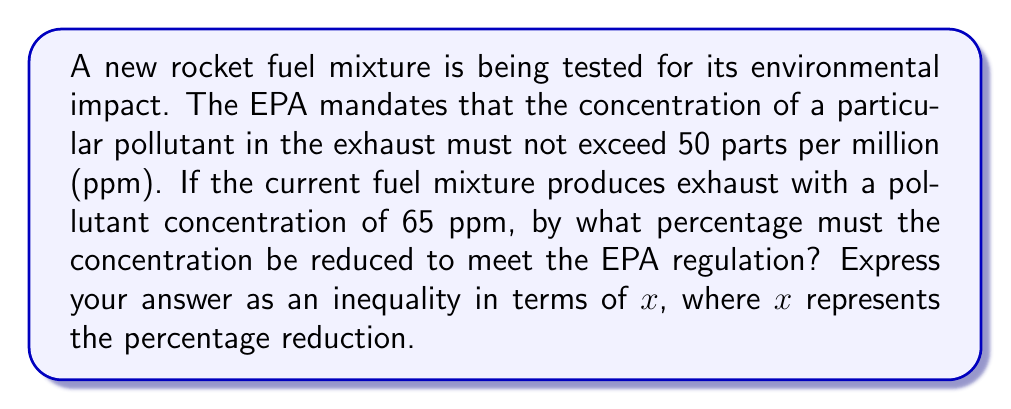Can you solve this math problem? Let's approach this step-by-step:

1) The current concentration is 65 ppm, and we need to reduce it to at most 50 ppm.

2) Let x be the percentage reduction. This means the new concentration will be:
   $65 - 65 \cdot \frac{x}{100}$ ppm

3) For the new concentration to meet the EPA regulation, we need:
   $65 - 65 \cdot \frac{x}{100} \leq 50$

4) Let's solve this inequality:
   $65 - 65 \cdot \frac{x}{100} \leq 50$
   $-65 \cdot \frac{x}{100} \leq 50 - 65$
   $-65 \cdot \frac{x}{100} \leq -15$
   $65 \cdot \frac{x}{100} \geq 15$
   $\frac{x}{100} \geq \frac{15}{65}$
   $x \geq \frac{1500}{65} \approx 23.08$

5) Therefore, the percentage reduction must be at least 23.08%.

6) We can express this as an inequality: $x \geq \frac{1500}{65}$
Answer: $x \geq \frac{1500}{65}$ 